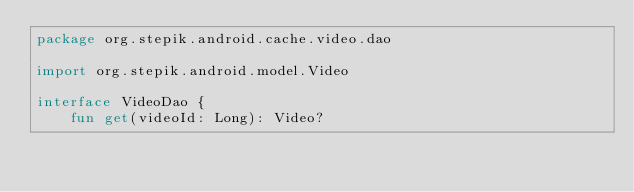Convert code to text. <code><loc_0><loc_0><loc_500><loc_500><_Kotlin_>package org.stepik.android.cache.video.dao

import org.stepik.android.model.Video

interface VideoDao {
    fun get(videoId: Long): Video?</code> 